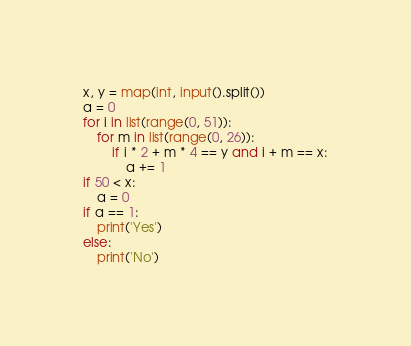<code> <loc_0><loc_0><loc_500><loc_500><_Python_>x, y = map(int, input().split())
a = 0
for i in list(range(0, 51)):
    for m in list(range(0, 26)):
        if i * 2 + m * 4 == y and i + m == x:
            a += 1
if 50 < x:
    a = 0
if a == 1:
    print('Yes')
else:
    print('No')
</code> 